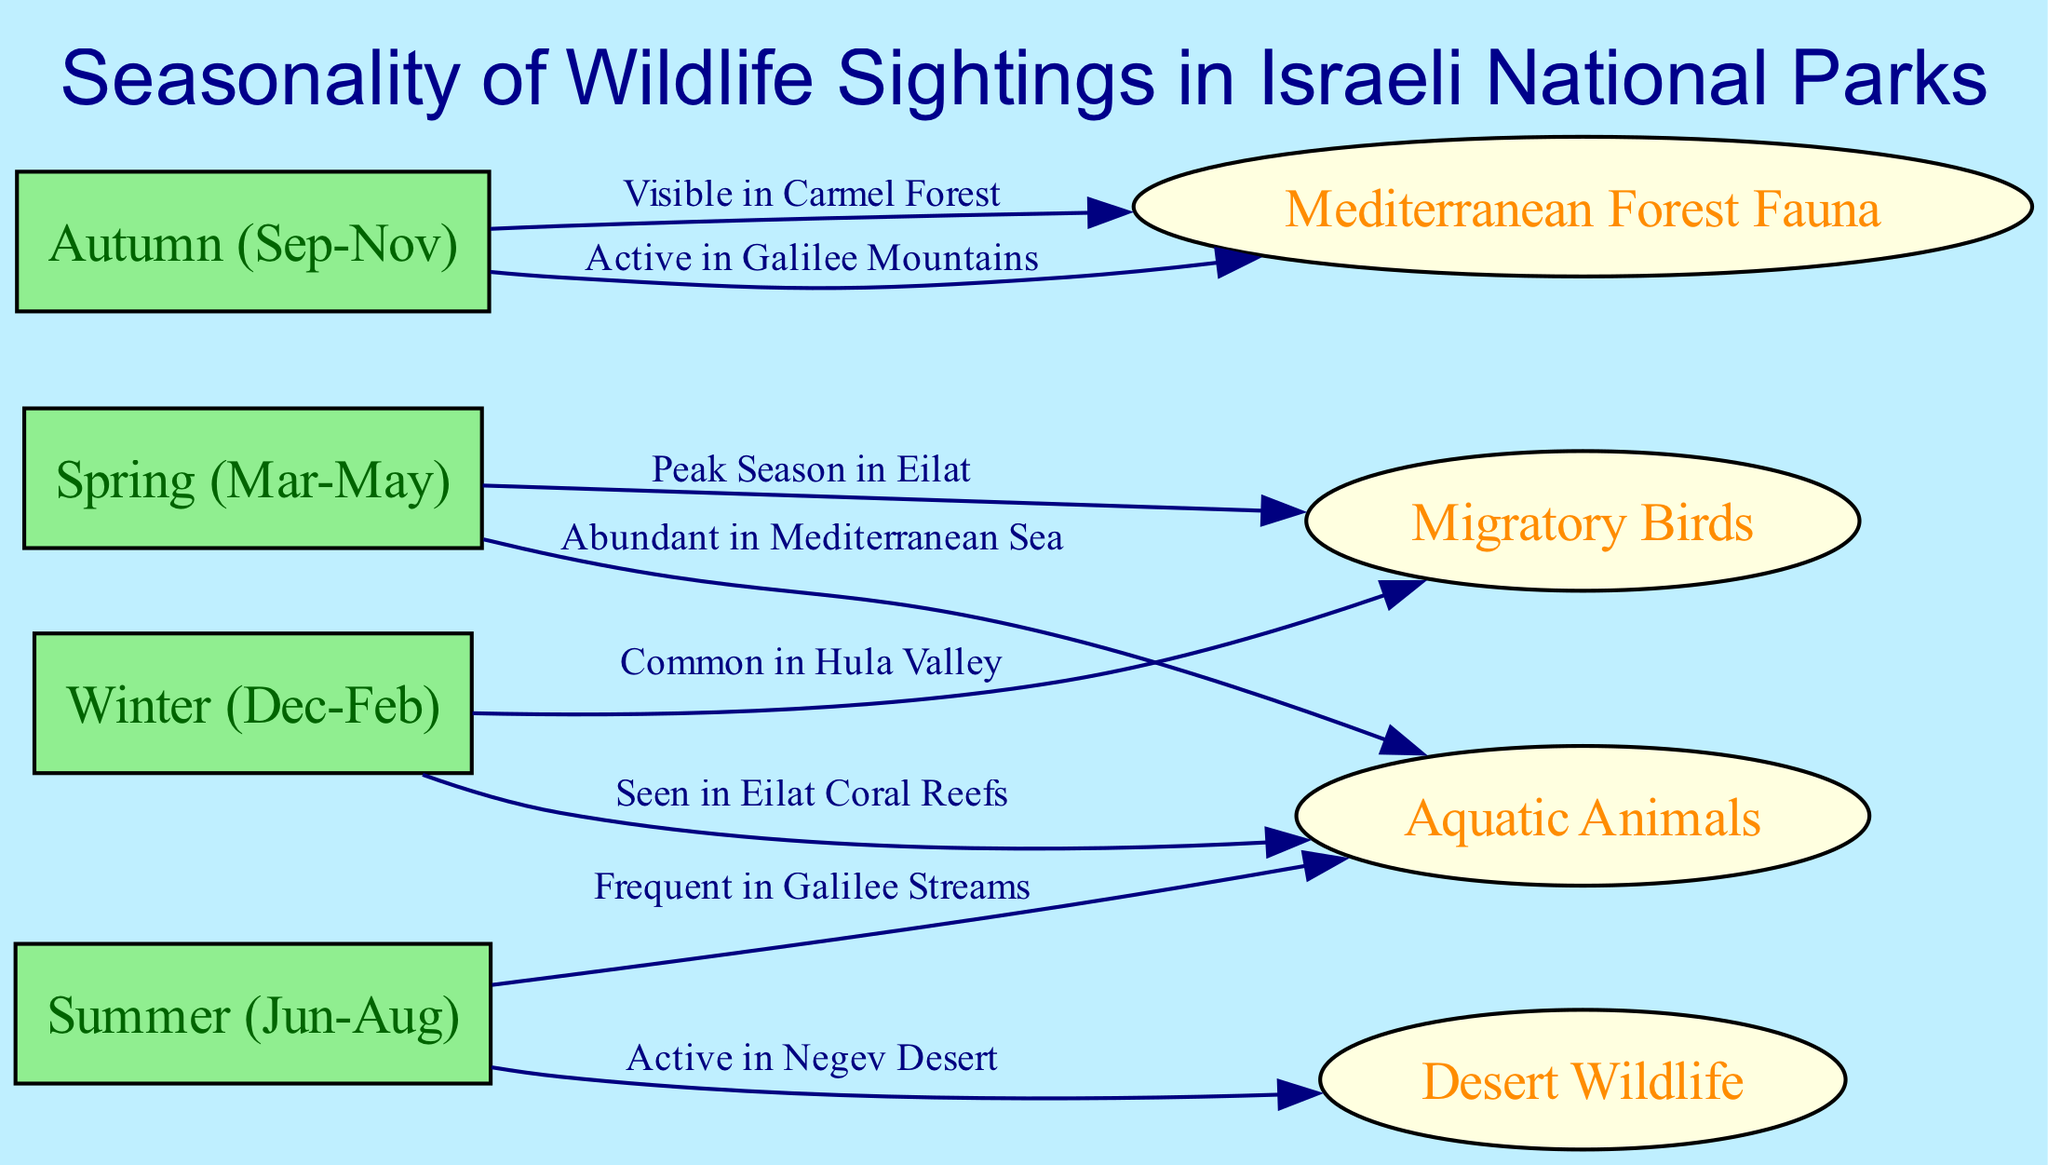What season is common for migratory birds in Hula Valley? The diagram shows an edge connecting "Winter" (node 1) to "Migratory Birds" (node 5) with a label indicating that migratory birds are common in Hula Valley during this season.
Answer: Winter (Dec-Feb) What wildlife is active in the Negev Desert? The edge from "Summer" (node 3) to "Desert Wildlife" (node 6) demonstrates that desert wildlife is most active during the summer months in this region.
Answer: Desert Wildlife During which season are aquatic animals abundant in the Mediterranean Sea? The diagram indicates that "Aquatic Animals" (node 8) are abundant during "Spring" (node 2), as shown by the edge between these two nodes.
Answer: Spring (Mar-May) How many nodes represent seasons in the diagram? The diagram includes four nodes labeled as seasons: Winter, Spring, Summer, and Autumn. Therefore, there are four nodes representing seasons.
Answer: 4 Which wildlife category is visible in the Carmel Forest during autumn? The edge connects "Autumn" (node 4) to "Mediterranean Forest Fauna" (node 7), indicating that this wildlife category is visible in the Carmel Forest during that season.
Answer: Mediterranean Forest Fauna What is the relationship between the season summer and aquatic animals? The diagram shows an edge from "Summer" (node 3) to "Aquatic Animals" (node 8) labeled "Frequent in Galilee Streams," which highlights that aquatic animals are seen during summer.
Answer: Frequent in Galilee Streams In which month does peak migratory bird season occur in Eilat? The link between "Spring" (node 2) and "Migratory Birds" (node 5) states that this is the peak season for migratory birds in Eilat, indicating it occurs in the spring months of March to May.
Answer: March to May What is the total number of edges in the diagram? The diagram contains a total of eight edges, which represent different relationships between seasons and wildlife categories.
Answer: 8 